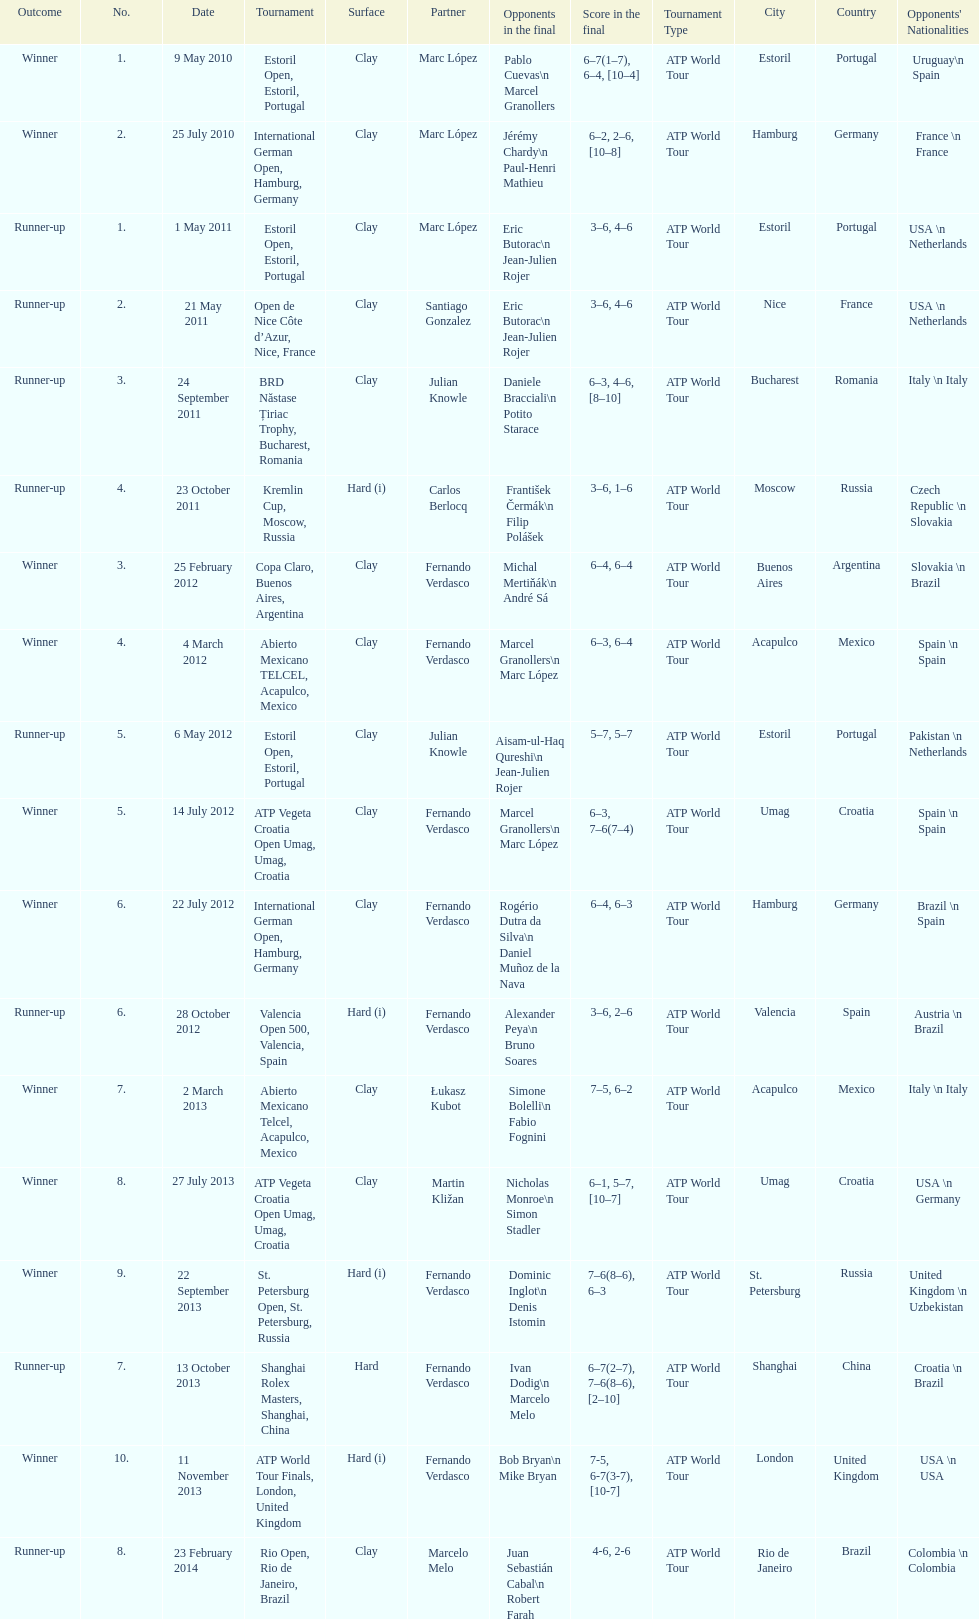Parse the table in full. {'header': ['Outcome', 'No.', 'Date', 'Tournament', 'Surface', 'Partner', 'Opponents in the final', 'Score in the final', 'Tournament Type', 'City', 'Country', "Opponents' Nationalities"], 'rows': [['Winner', '1.', '9 May 2010', 'Estoril Open, Estoril, Portugal', 'Clay', 'Marc López', 'Pablo Cuevas\\n Marcel Granollers', '6–7(1–7), 6–4, [10–4]', 'ATP World Tour', 'Estoril', 'Portugal', 'Uruguay\\n Spain'], ['Winner', '2.', '25 July 2010', 'International German Open, Hamburg, Germany', 'Clay', 'Marc López', 'Jérémy Chardy\\n Paul-Henri Mathieu', '6–2, 2–6, [10–8]', 'ATP World Tour', 'Hamburg', 'Germany', 'France \\n France'], ['Runner-up', '1.', '1 May 2011', 'Estoril Open, Estoril, Portugal', 'Clay', 'Marc López', 'Eric Butorac\\n Jean-Julien Rojer', '3–6, 4–6', 'ATP World Tour', 'Estoril', 'Portugal', 'USA \\n Netherlands'], ['Runner-up', '2.', '21 May 2011', 'Open de Nice Côte d’Azur, Nice, France', 'Clay', 'Santiago Gonzalez', 'Eric Butorac\\n Jean-Julien Rojer', '3–6, 4–6', 'ATP World Tour', 'Nice', 'France', 'USA \\n Netherlands'], ['Runner-up', '3.', '24 September 2011', 'BRD Năstase Țiriac Trophy, Bucharest, Romania', 'Clay', 'Julian Knowle', 'Daniele Bracciali\\n Potito Starace', '6–3, 4–6, [8–10]', 'ATP World Tour', 'Bucharest', 'Romania', 'Italy \\n Italy'], ['Runner-up', '4.', '23 October 2011', 'Kremlin Cup, Moscow, Russia', 'Hard (i)', 'Carlos Berlocq', 'František Čermák\\n Filip Polášek', '3–6, 1–6', 'ATP World Tour', 'Moscow', 'Russia', 'Czech Republic \\n Slovakia'], ['Winner', '3.', '25 February 2012', 'Copa Claro, Buenos Aires, Argentina', 'Clay', 'Fernando Verdasco', 'Michal Mertiňák\\n André Sá', '6–4, 6–4', 'ATP World Tour', 'Buenos Aires', 'Argentina', 'Slovakia \\n Brazil'], ['Winner', '4.', '4 March 2012', 'Abierto Mexicano TELCEL, Acapulco, Mexico', 'Clay', 'Fernando Verdasco', 'Marcel Granollers\\n Marc López', '6–3, 6–4', 'ATP World Tour', 'Acapulco', 'Mexico', 'Spain \\n Spain'], ['Runner-up', '5.', '6 May 2012', 'Estoril Open, Estoril, Portugal', 'Clay', 'Julian Knowle', 'Aisam-ul-Haq Qureshi\\n Jean-Julien Rojer', '5–7, 5–7', 'ATP World Tour', 'Estoril', 'Portugal', 'Pakistan \\n Netherlands'], ['Winner', '5.', '14 July 2012', 'ATP Vegeta Croatia Open Umag, Umag, Croatia', 'Clay', 'Fernando Verdasco', 'Marcel Granollers\\n Marc López', '6–3, 7–6(7–4)', 'ATP World Tour', 'Umag', 'Croatia', 'Spain \\n Spain'], ['Winner', '6.', '22 July 2012', 'International German Open, Hamburg, Germany', 'Clay', 'Fernando Verdasco', 'Rogério Dutra da Silva\\n Daniel Muñoz de la Nava', '6–4, 6–3', 'ATP World Tour', 'Hamburg', 'Germany', 'Brazil \\n Spain'], ['Runner-up', '6.', '28 October 2012', 'Valencia Open 500, Valencia, Spain', 'Hard (i)', 'Fernando Verdasco', 'Alexander Peya\\n Bruno Soares', '3–6, 2–6', 'ATP World Tour', 'Valencia', 'Spain', 'Austria \\n Brazil'], ['Winner', '7.', '2 March 2013', 'Abierto Mexicano Telcel, Acapulco, Mexico', 'Clay', 'Łukasz Kubot', 'Simone Bolelli\\n Fabio Fognini', '7–5, 6–2', 'ATP World Tour', 'Acapulco', 'Mexico', 'Italy \\n Italy'], ['Winner', '8.', '27 July 2013', 'ATP Vegeta Croatia Open Umag, Umag, Croatia', 'Clay', 'Martin Kližan', 'Nicholas Monroe\\n Simon Stadler', '6–1, 5–7, [10–7]', 'ATP World Tour', 'Umag', 'Croatia', 'USA \\n Germany'], ['Winner', '9.', '22 September 2013', 'St. Petersburg Open, St. Petersburg, Russia', 'Hard (i)', 'Fernando Verdasco', 'Dominic Inglot\\n Denis Istomin', '7–6(8–6), 6–3', 'ATP World Tour', 'St. Petersburg', 'Russia', 'United Kingdom \\n Uzbekistan'], ['Runner-up', '7.', '13 October 2013', 'Shanghai Rolex Masters, Shanghai, China', 'Hard', 'Fernando Verdasco', 'Ivan Dodig\\n Marcelo Melo', '6–7(2–7), 7–6(8–6), [2–10]', 'ATP World Tour', 'Shanghai', 'China', 'Croatia \\n Brazil'], ['Winner', '10.', '11 November 2013', 'ATP World Tour Finals, London, United Kingdom', 'Hard (i)', 'Fernando Verdasco', 'Bob Bryan\\n Mike Bryan', '7-5, 6-7(3-7), [10-7]', 'ATP World Tour', 'London', 'United Kingdom', 'USA \\n USA'], ['Runner-up', '8.', '23 February 2014', 'Rio Open, Rio de Janeiro, Brazil', 'Clay', 'Marcelo Melo', 'Juan Sebastián Cabal\\n Robert Farah', '4-6, 2-6', 'ATP World Tour', 'Rio de Janeiro', 'Brazil', 'Colombia \\n Colombia']]} Which competition preceded the estoril open? Abierto Mexicano TELCEL, Acapulco, Mexico. 